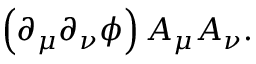Convert formula to latex. <formula><loc_0><loc_0><loc_500><loc_500>\left ( \partial _ { \mu } \partial _ { \nu } \phi \right ) A _ { \mu } A _ { \nu } .</formula> 